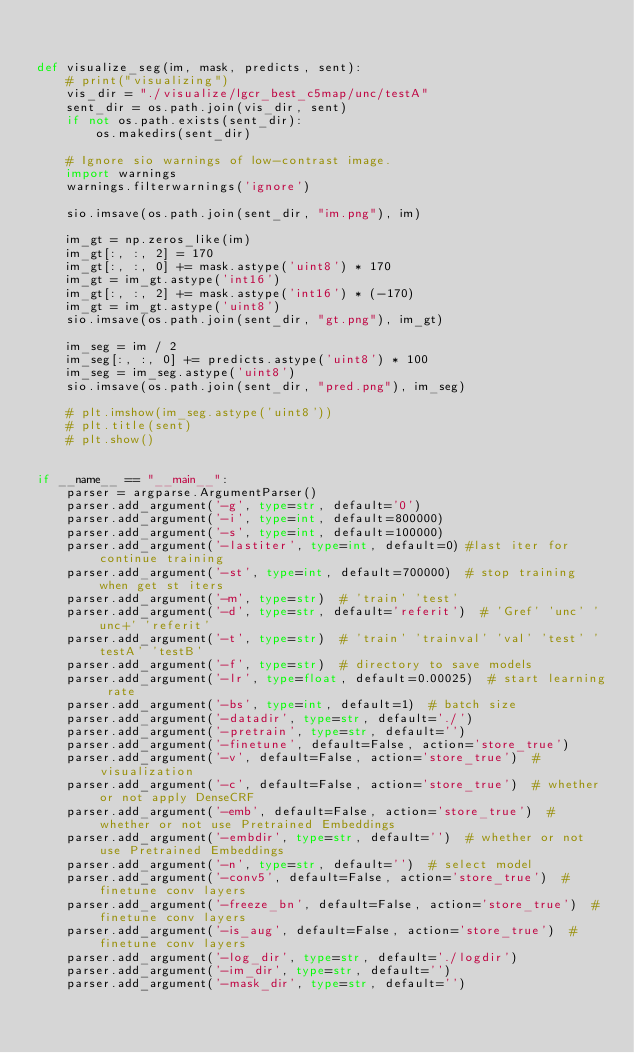Convert code to text. <code><loc_0><loc_0><loc_500><loc_500><_Python_>

def visualize_seg(im, mask, predicts, sent):
    # print("visualizing")
    vis_dir = "./visualize/lgcr_best_c5map/unc/testA"
    sent_dir = os.path.join(vis_dir, sent)
    if not os.path.exists(sent_dir):
        os.makedirs(sent_dir)

    # Ignore sio warnings of low-contrast image.
    import warnings
    warnings.filterwarnings('ignore')

    sio.imsave(os.path.join(sent_dir, "im.png"), im)

    im_gt = np.zeros_like(im)
    im_gt[:, :, 2] = 170
    im_gt[:, :, 0] += mask.astype('uint8') * 170
    im_gt = im_gt.astype('int16')
    im_gt[:, :, 2] += mask.astype('int16') * (-170)
    im_gt = im_gt.astype('uint8')
    sio.imsave(os.path.join(sent_dir, "gt.png"), im_gt)

    im_seg = im / 2
    im_seg[:, :, 0] += predicts.astype('uint8') * 100
    im_seg = im_seg.astype('uint8')
    sio.imsave(os.path.join(sent_dir, "pred.png"), im_seg)

    # plt.imshow(im_seg.astype('uint8'))
    # plt.title(sent)
    # plt.show()


if __name__ == "__main__":
    parser = argparse.ArgumentParser()
    parser.add_argument('-g', type=str, default='0')
    parser.add_argument('-i', type=int, default=800000)
    parser.add_argument('-s', type=int, default=100000)
    parser.add_argument('-lastiter', type=int, default=0) #last iter for continue training
    parser.add_argument('-st', type=int, default=700000)  # stop training when get st iters
    parser.add_argument('-m', type=str)  # 'train' 'test'
    parser.add_argument('-d', type=str, default='referit')  # 'Gref' 'unc' 'unc+' 'referit'
    parser.add_argument('-t', type=str)  # 'train' 'trainval' 'val' 'test' 'testA' 'testB'
    parser.add_argument('-f', type=str)  # directory to save models
    parser.add_argument('-lr', type=float, default=0.00025)  # start learning rate
    parser.add_argument('-bs', type=int, default=1)  # batch size
    parser.add_argument('-datadir', type=str, default='./')
    parser.add_argument('-pretrain', type=str, default='')
    parser.add_argument('-finetune', default=False, action='store_true') 
    parser.add_argument('-v', default=False, action='store_true')  # visualization
    parser.add_argument('-c', default=False, action='store_true')  # whether or not apply DenseCRF
    parser.add_argument('-emb', default=False, action='store_true')  # whether or not use Pretrained Embeddings
    parser.add_argument('-embdir', type=str, default='')  # whether or not use Pretrained Embeddings
    parser.add_argument('-n', type=str, default='')  # select model
    parser.add_argument('-conv5', default=False, action='store_true')  # finetune conv layers
    parser.add_argument('-freeze_bn', default=False, action='store_true')  # finetune conv layers
    parser.add_argument('-is_aug', default=False, action='store_true')  # finetune conv layers
    parser.add_argument('-log_dir', type=str, default='./logdir')
    parser.add_argument('-im_dir', type=str, default='')
    parser.add_argument('-mask_dir', type=str, default='')</code> 